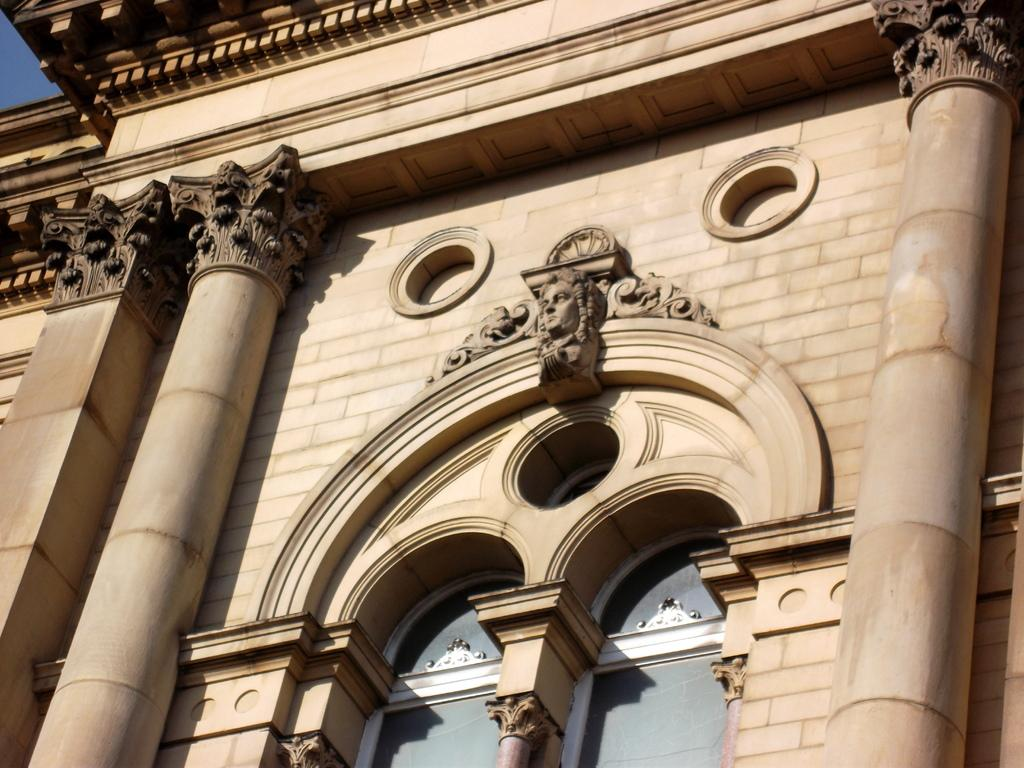What type of structure is depicted in the image? There is a historical building in the image. What architectural features can be seen on the building? The building has sculptures and two pillars. What can be seen in the background of the image? The sky is visible in the background of the image. What type of zipper can be seen on the building in the image? There is no zipper present on the building in the image. What is the weather like in the image? The provided facts do not mention the weather, so it cannot be determined from the image. 